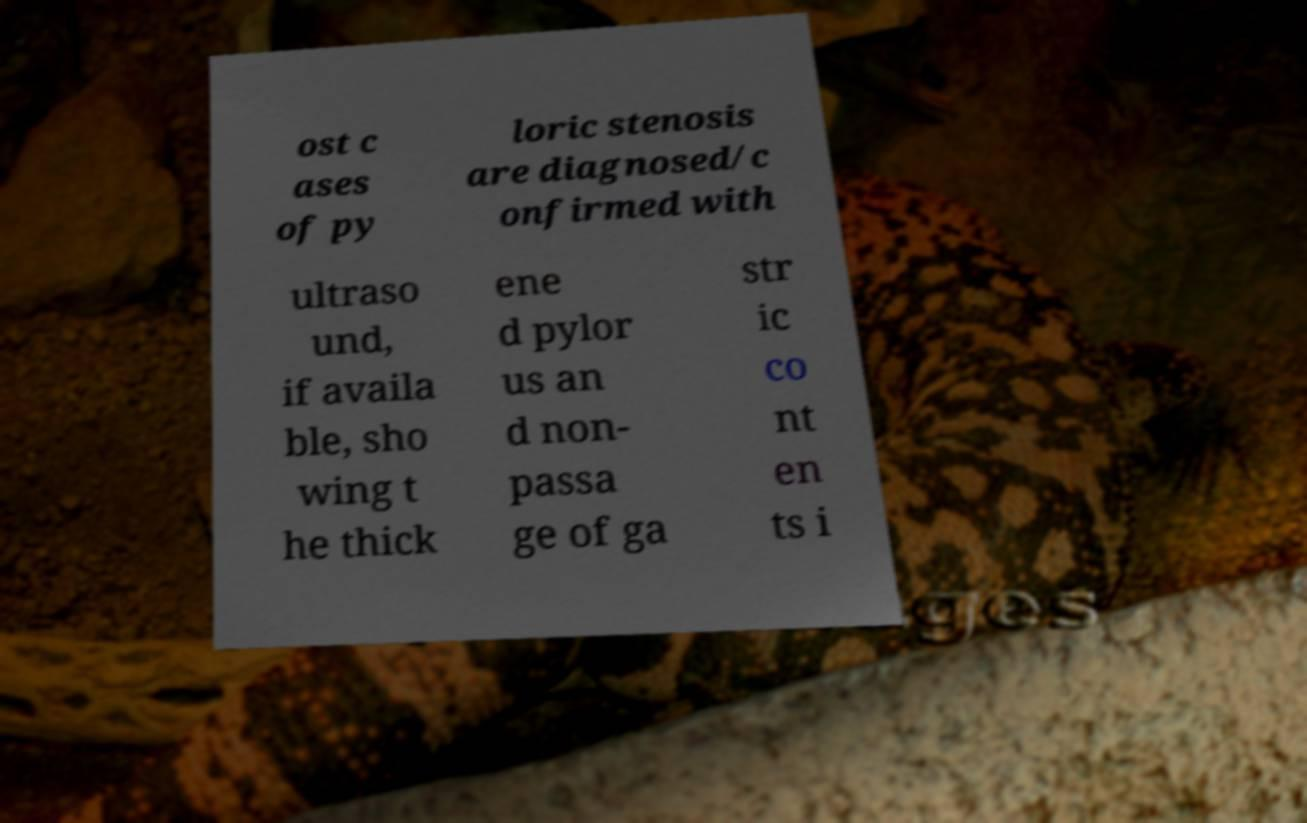Please read and relay the text visible in this image. What does it say? ost c ases of py loric stenosis are diagnosed/c onfirmed with ultraso und, if availa ble, sho wing t he thick ene d pylor us an d non- passa ge of ga str ic co nt en ts i 